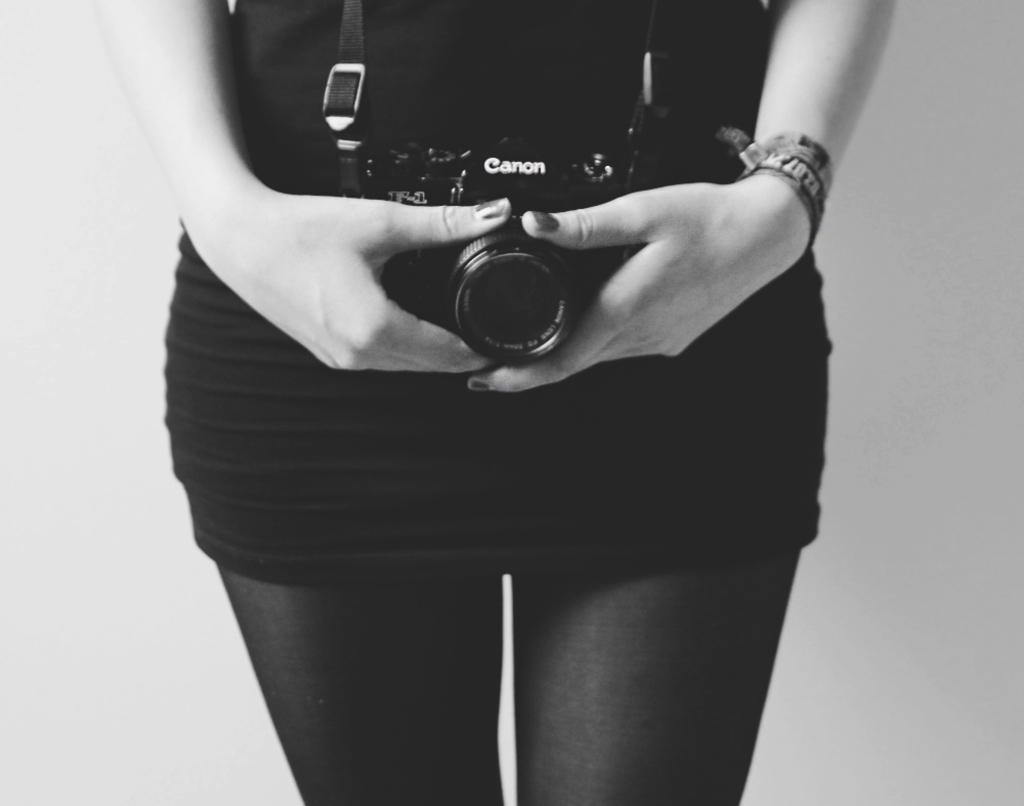Who is the main subject in the image? There is a woman in the image. What is the woman wearing? The woman is wearing a black dress. What is the woman doing in the image? The woman is standing in the image. What object is the woman holding in her hand? The woman is holding a camera in her hand. How much wealth does the cushion in the image possess? There is no cushion present in the image, so it is not possible to determine its wealth. 